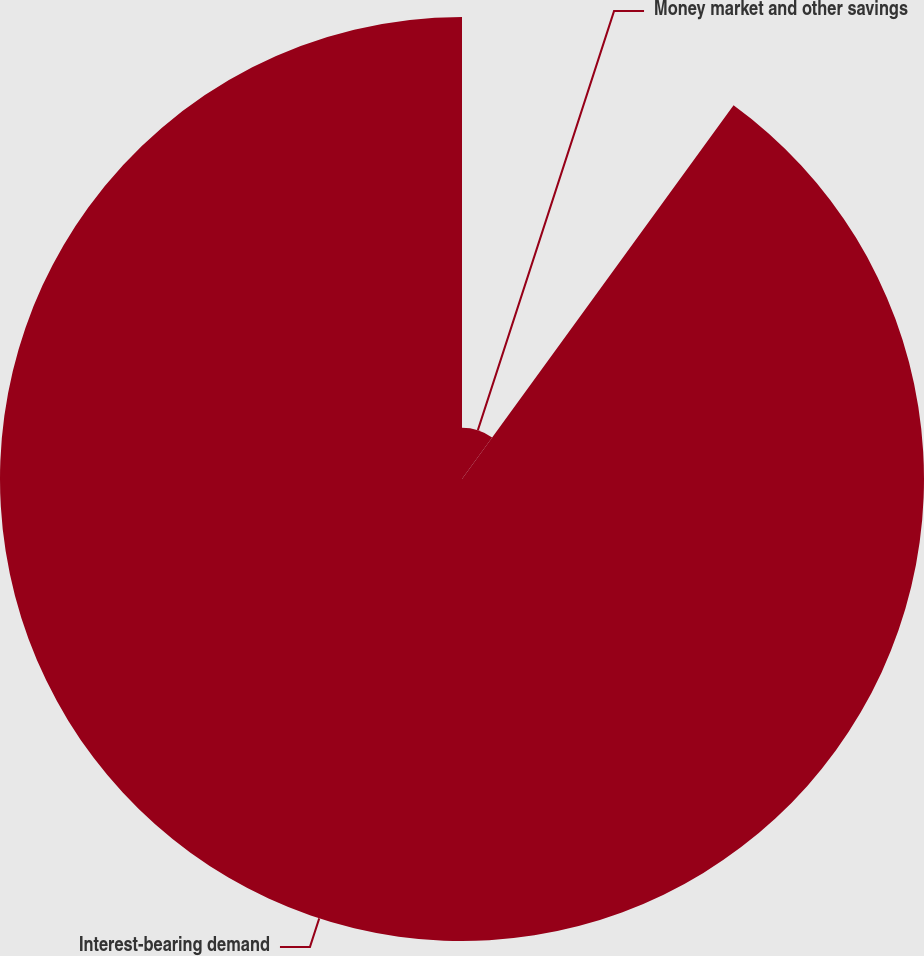Convert chart. <chart><loc_0><loc_0><loc_500><loc_500><pie_chart><fcel>Money market and other savings<fcel>Interest-bearing demand<nl><fcel>10.0%<fcel>90.0%<nl></chart> 